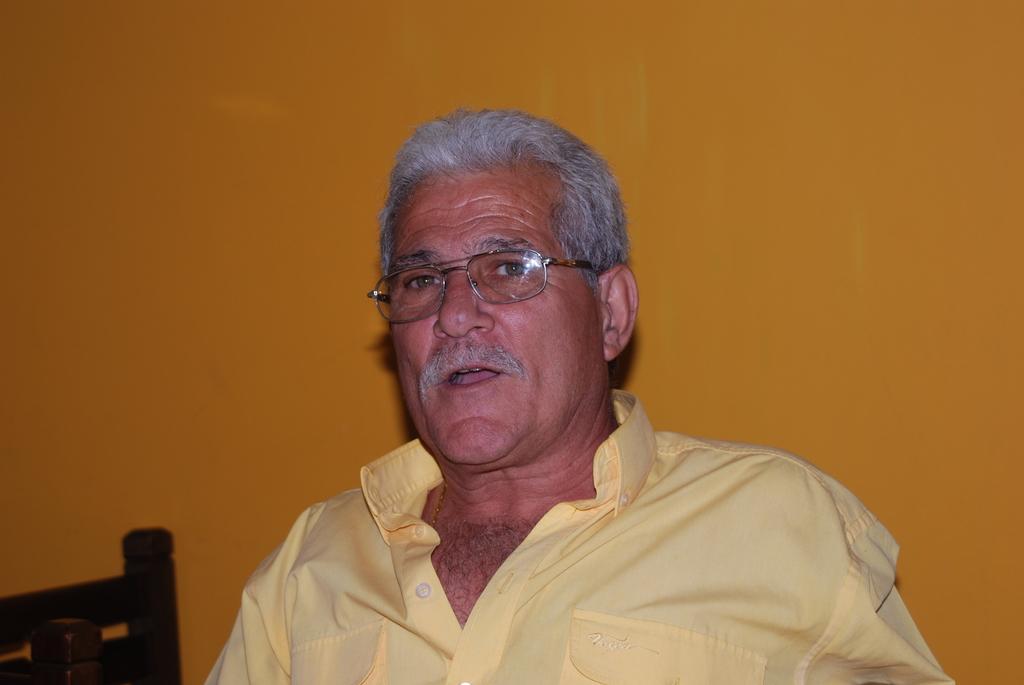How would you summarize this image in a sentence or two? In this image I can see the person wearing the yellow color dress and specs. There is a yellow color background. 